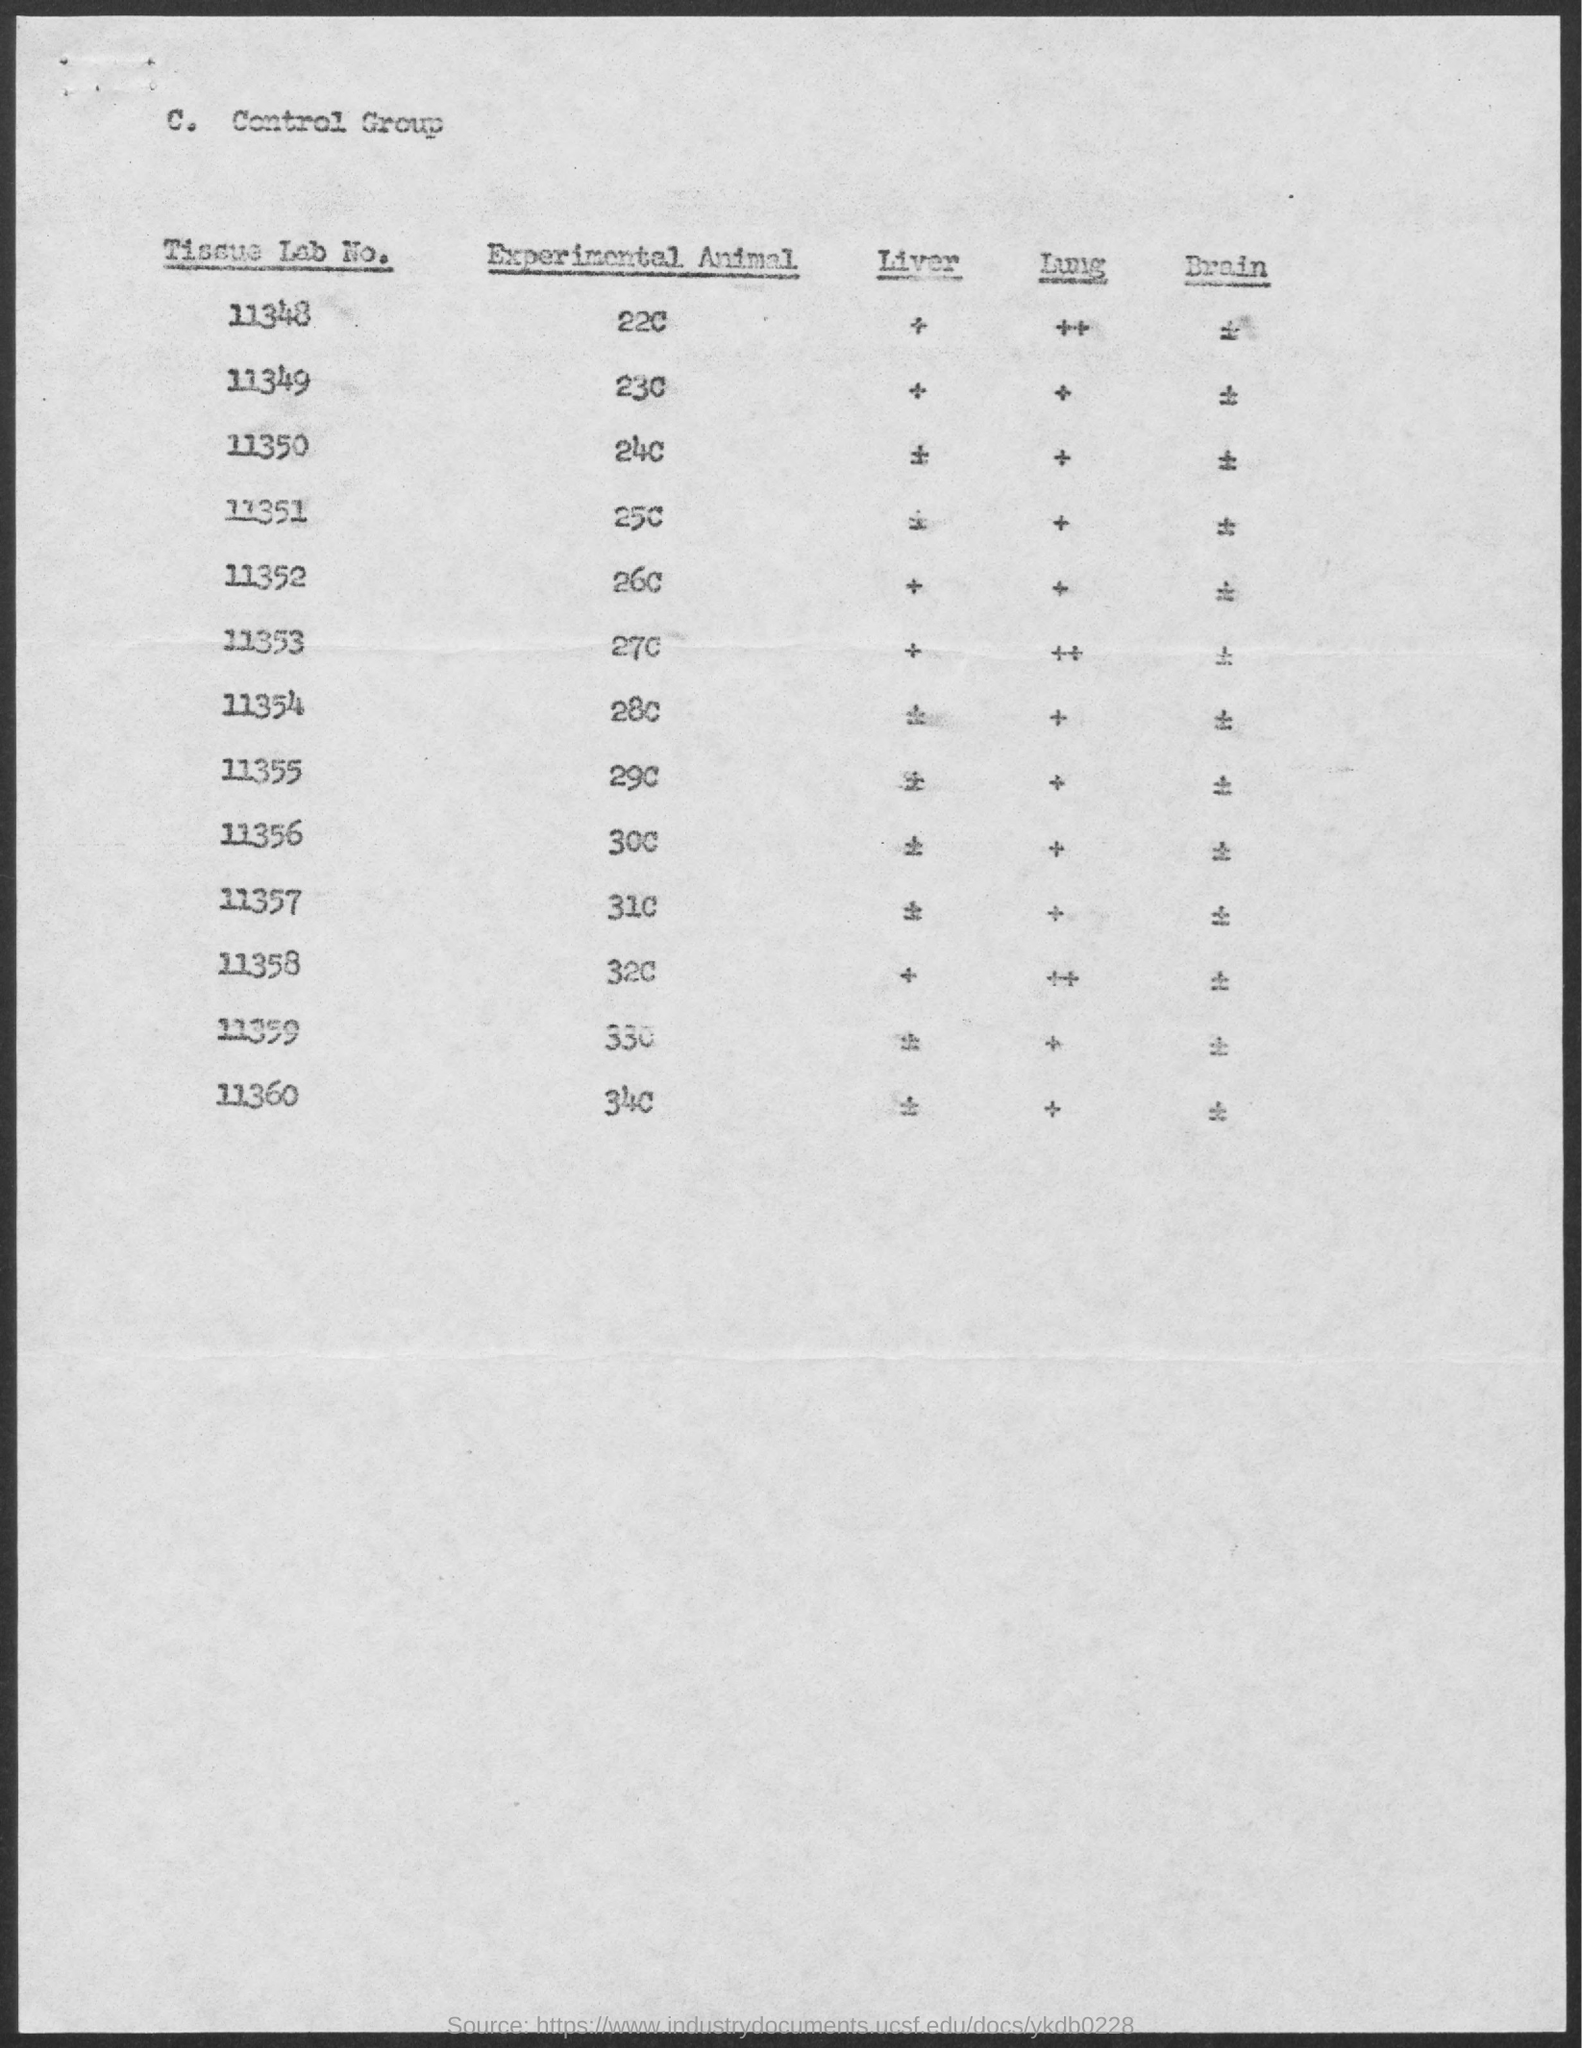What is the value of experimental animal for the tissue lab no. 11348 ?
Provide a succinct answer. 22c. What is the value of experimental animal for the tissue lab no. 11353?
Your answer should be very brief. 27c. What is the value of experimental animal for the tissue lab no. 11360 ?
Provide a succinct answer. 34c. What is the tissue lab no. for the value of 25c of experimental animal ?
Provide a succinct answer. 11351. What is the value of experimental animal for the tissue lab no. 11358 ?
Your response must be concise. 32c. What is the value of experimental animal for the tissue lab no. 11359 ?
Your answer should be compact. 33c. 